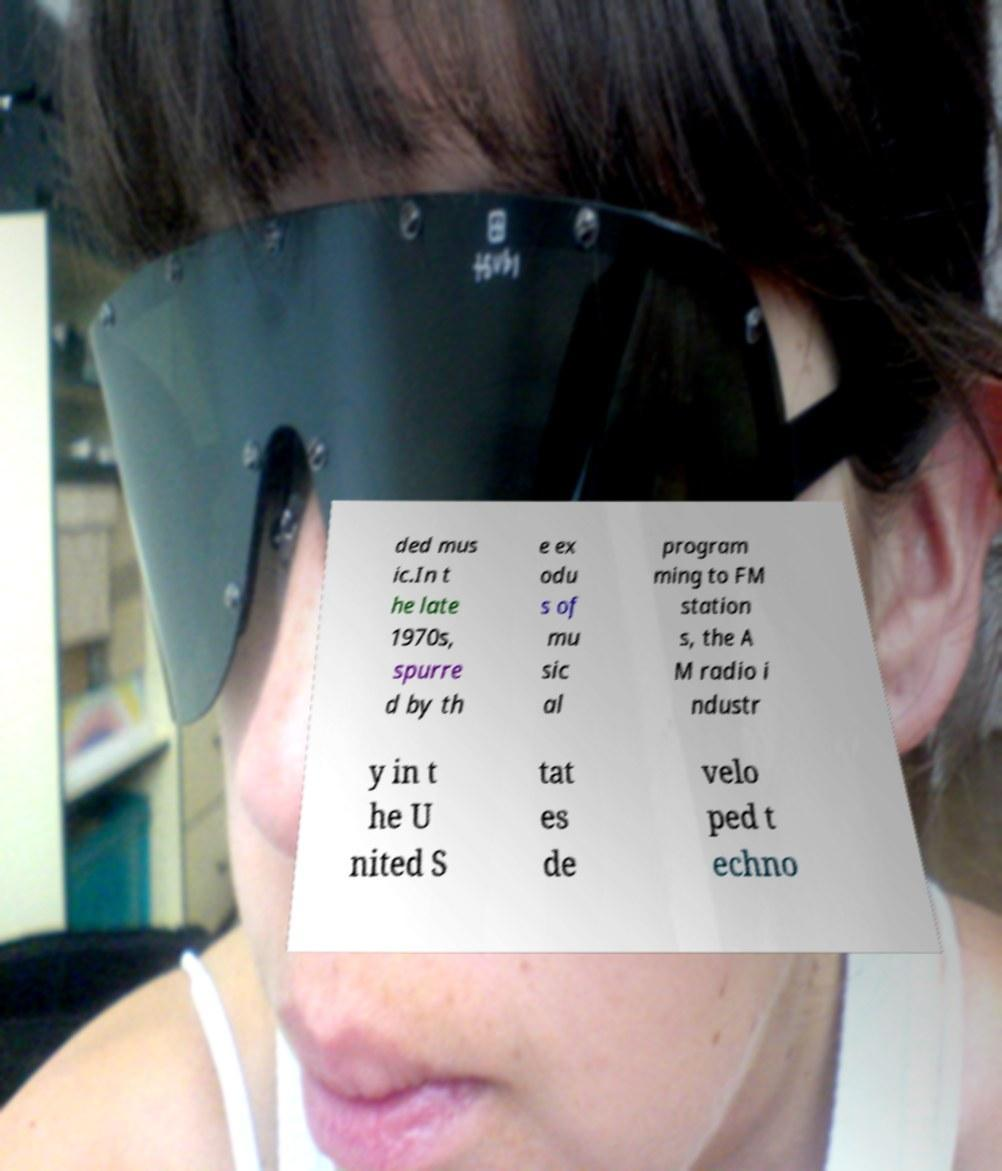What messages or text are displayed in this image? I need them in a readable, typed format. ded mus ic.In t he late 1970s, spurre d by th e ex odu s of mu sic al program ming to FM station s, the A M radio i ndustr y in t he U nited S tat es de velo ped t echno 